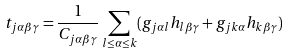<formula> <loc_0><loc_0><loc_500><loc_500>t _ { j \alpha \beta \gamma } = \frac { 1 } { C _ { j \alpha \beta \gamma } } \sum _ { l \leq \alpha \leq k } ( g _ { j \alpha l } h _ { l \beta \gamma } + g _ { j k \alpha } h _ { k \beta \gamma } )</formula> 